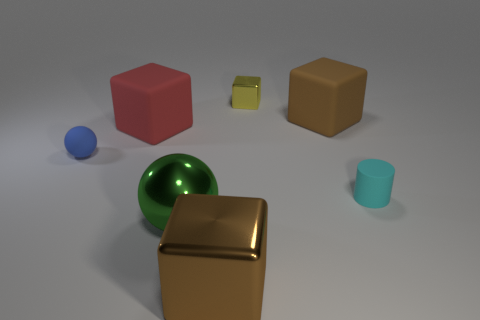Subtract all brown cylinders. Subtract all brown blocks. How many cylinders are left? 1 Add 3 large blocks. How many objects exist? 10 Subtract all cubes. How many objects are left? 3 Subtract 0 blue cylinders. How many objects are left? 7 Subtract all blue things. Subtract all metallic blocks. How many objects are left? 4 Add 7 brown metal things. How many brown metal things are left? 8 Add 3 big matte blocks. How many big matte blocks exist? 5 